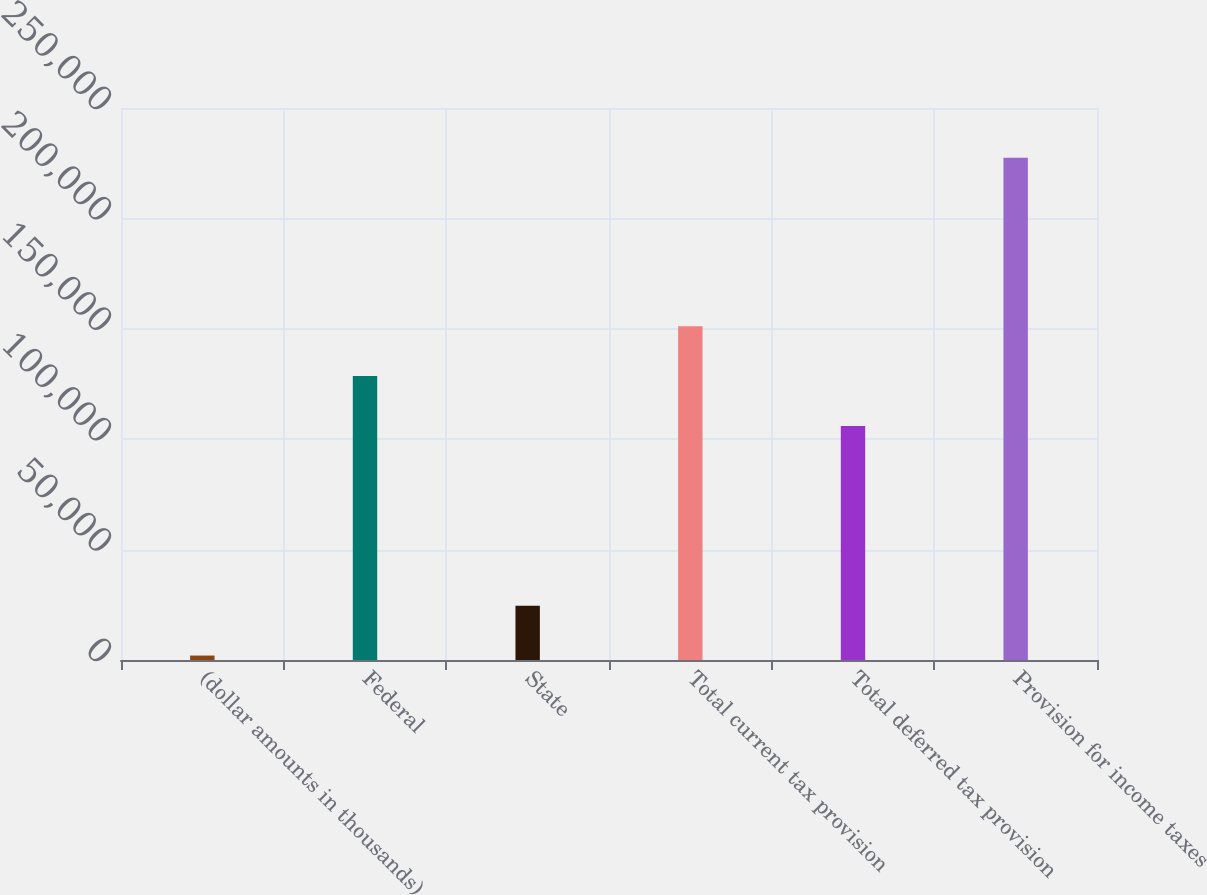Convert chart. <chart><loc_0><loc_0><loc_500><loc_500><bar_chart><fcel>(dollar amounts in thousands)<fcel>Federal<fcel>State<fcel>Total current tax provision<fcel>Total deferred tax provision<fcel>Provision for income taxes<nl><fcel>2013<fcel>128568<fcel>24559.1<fcel>151114<fcel>106022<fcel>227474<nl></chart> 